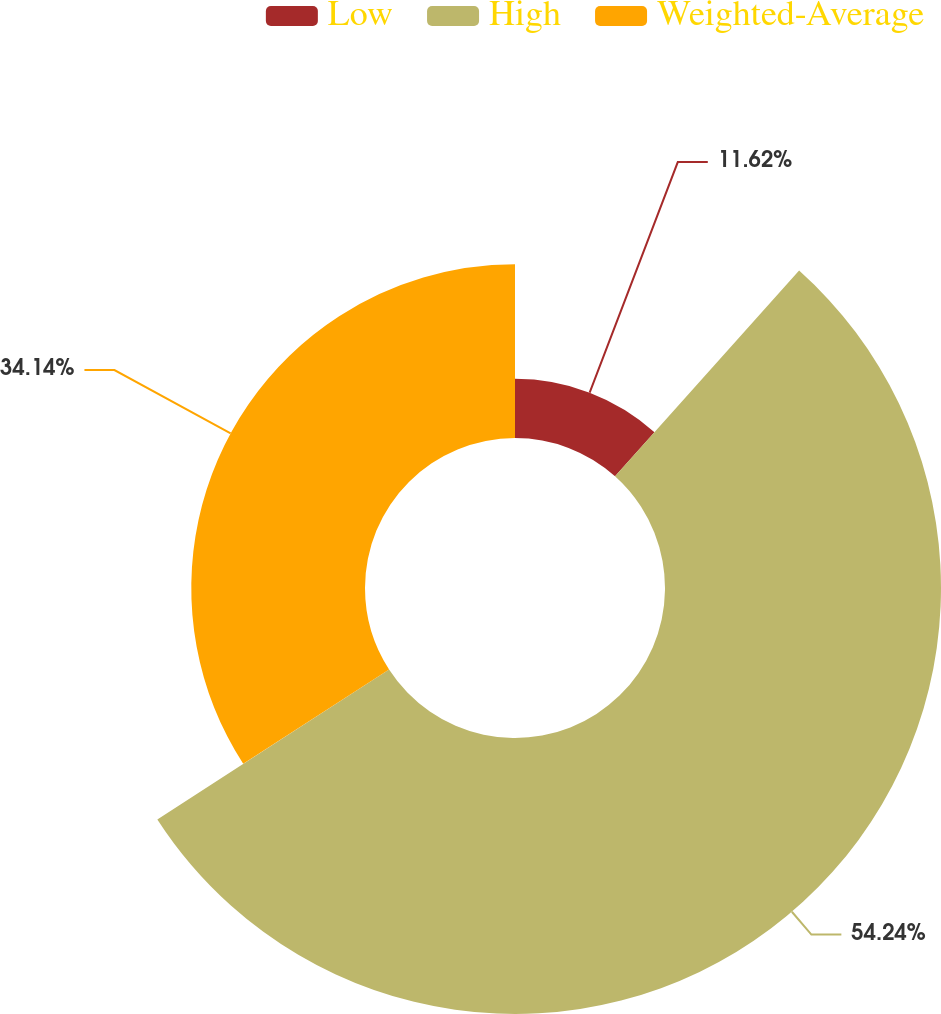Convert chart. <chart><loc_0><loc_0><loc_500><loc_500><pie_chart><fcel>Low<fcel>High<fcel>Weighted-Average<nl><fcel>11.62%<fcel>54.24%<fcel>34.14%<nl></chart> 